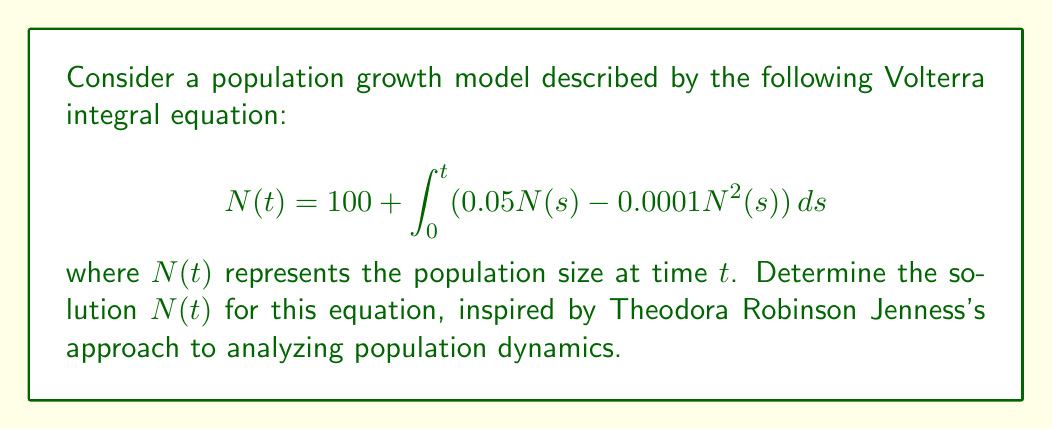Can you solve this math problem? To solve this Volterra integral equation, we'll follow these steps:

1) First, we recognize that this equation represents a logistic growth model. The initial population is 100, and the growth rate is 0.05 with a carrying capacity factor of 0.0001.

2) To solve this, we'll differentiate both sides with respect to $t$:

   $$\frac{dN}{dt} = 0.05N(t) - 0.0001N^2(t)$$

3) This is now a separable differential equation. We can rewrite it as:

   $$\frac{dN}{0.05N - 0.0001N^2} = dt$$

4) Integrate both sides:

   $$\int \frac{dN}{0.05N - 0.0001N^2} = \int dt$$

5) The left side can be integrated using partial fractions:

   $$\frac{1}{0.05} \ln\left|\frac{N}{500-N}\right| = t + C$$

6) Solve for $N$:

   $$\frac{N}{500-N} = Ae^{0.05t}$$

   where $A = e^{0.05C}$

7) Rearrange to get $N$ alone:

   $$N = \frac{500Ae^{0.05t}}{1 + Ae^{0.05t}}$$

8) Use the initial condition $N(0) = 100$ to find $A$:

   $$100 = \frac{500A}{1 + A}$$

   Solving this, we get $A = \frac{1}{4}$

9) Therefore, the final solution is:

   $$N(t) = \frac{500(\frac{1}{4})e^{0.05t}}{1 + (\frac{1}{4})e^{0.05t}} = \frac{125e^{0.05t}}{1 + 0.25e^{0.05t}}$$
Answer: $N(t) = \frac{125e^{0.05t}}{1 + 0.25e^{0.05t}}$ 